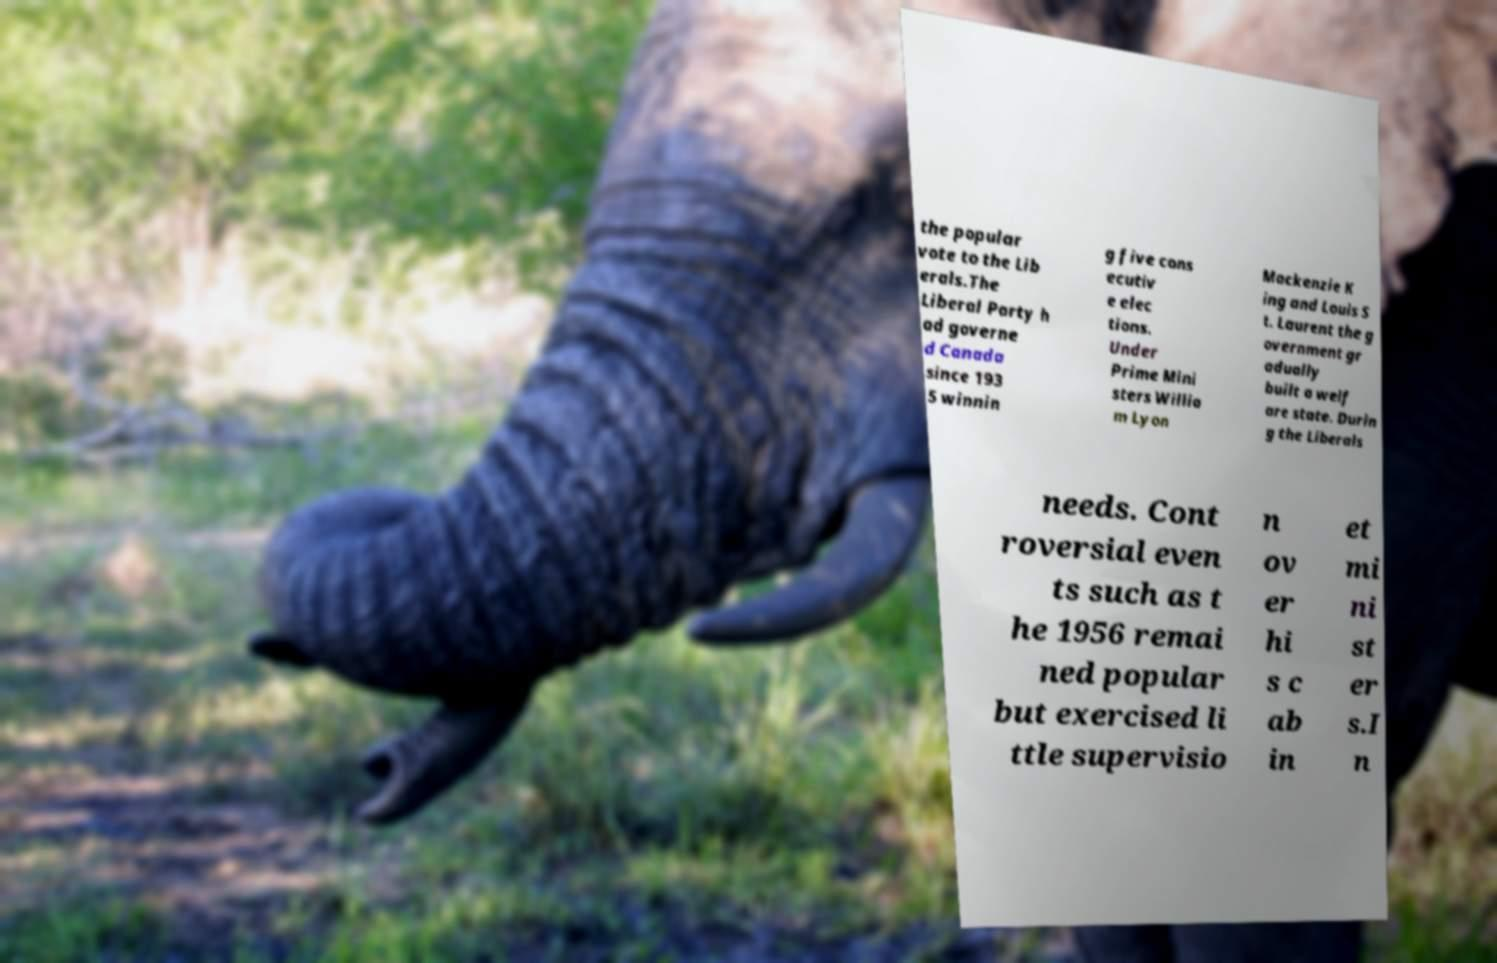For documentation purposes, I need the text within this image transcribed. Could you provide that? the popular vote to the Lib erals.The Liberal Party h ad governe d Canada since 193 5 winnin g five cons ecutiv e elec tions. Under Prime Mini sters Willia m Lyon Mackenzie K ing and Louis S t. Laurent the g overnment gr adually built a welf are state. Durin g the Liberals needs. Cont roversial even ts such as t he 1956 remai ned popular but exercised li ttle supervisio n ov er hi s c ab in et mi ni st er s.I n 